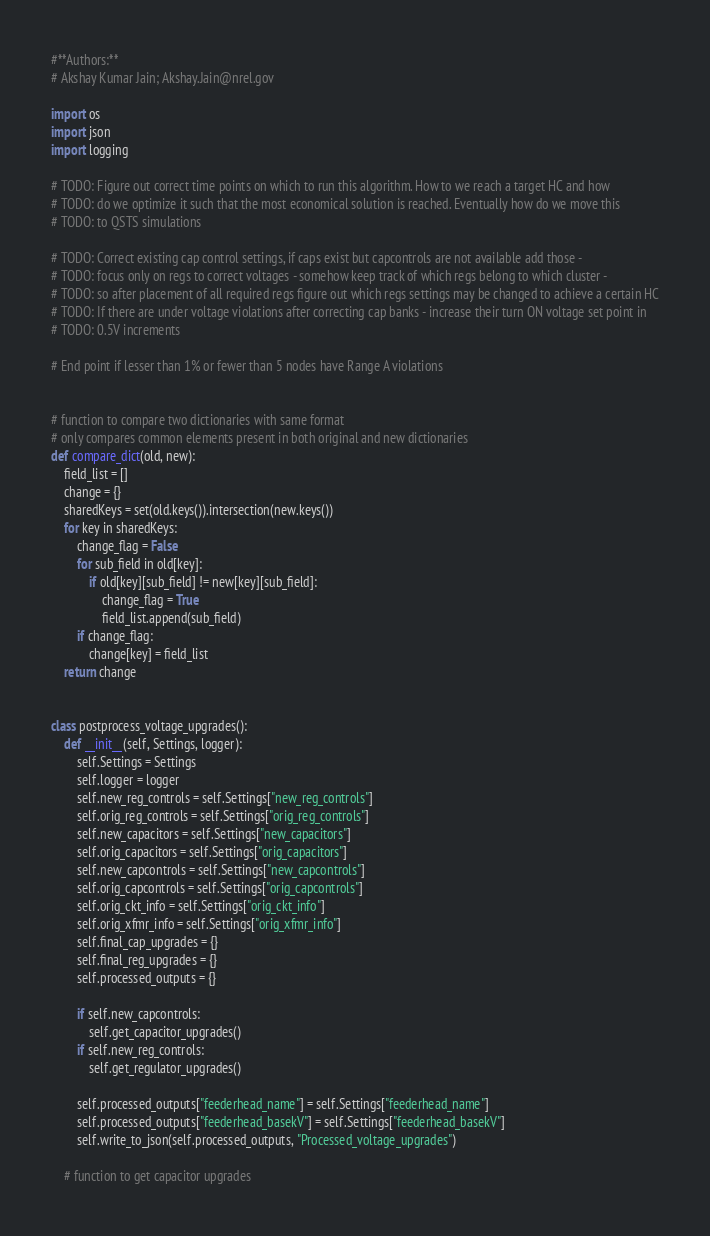<code> <loc_0><loc_0><loc_500><loc_500><_Python_>#**Authors:**
# Akshay Kumar Jain; Akshay.Jain@nrel.gov

import os
import json
import logging

# TODO: Figure out correct time points on which to run this algorithm. How to we reach a target HC and how
# TODO: do we optimize it such that the most economical solution is reached. Eventually how do we move this
# TODO: to QSTS simulations

# TODO: Correct existing cap control settings, if caps exist but capcontrols are not available add those -
# TODO: focus only on regs to correct voltages - somehow keep track of which regs belong to which cluster -
# TODO: so after placement of all required regs figure out which regs settings may be changed to achieve a certain HC
# TODO: If there are under voltage violations after correcting cap banks - increase their turn ON voltage set point in
# TODO: 0.5V increments

# End point if lesser than 1% or fewer than 5 nodes have Range A violations


# function to compare two dictionaries with same format
# only compares common elements present in both original and new dictionaries
def compare_dict(old, new):
    field_list = []
    change = {}
    sharedKeys = set(old.keys()).intersection(new.keys())
    for key in sharedKeys:
        change_flag = False
        for sub_field in old[key]:
            if old[key][sub_field] != new[key][sub_field]:
                change_flag = True
                field_list.append(sub_field)
        if change_flag:
            change[key] = field_list
    return change


class postprocess_voltage_upgrades():
    def __init__(self, Settings, logger):
        self.Settings = Settings
        self.logger = logger
        self.new_reg_controls = self.Settings["new_reg_controls"]
        self.orig_reg_controls = self.Settings["orig_reg_controls"]
        self.new_capacitors = self.Settings["new_capacitors"]
        self.orig_capacitors = self.Settings["orig_capacitors"]
        self.new_capcontrols = self.Settings["new_capcontrols"]
        self.orig_capcontrols = self.Settings["orig_capcontrols"]
        self.orig_ckt_info = self.Settings["orig_ckt_info"]
        self.orig_xfmr_info = self.Settings["orig_xfmr_info"]
        self.final_cap_upgrades = {}
        self.final_reg_upgrades = {}
        self.processed_outputs = {}

        if self.new_capcontrols:
            self.get_capacitor_upgrades()
        if self.new_reg_controls:
            self.get_regulator_upgrades()

        self.processed_outputs["feederhead_name"] = self.Settings["feederhead_name"]
        self.processed_outputs["feederhead_basekV"] = self.Settings["feederhead_basekV"]
        self.write_to_json(self.processed_outputs, "Processed_voltage_upgrades")

    # function to get capacitor upgrades</code> 